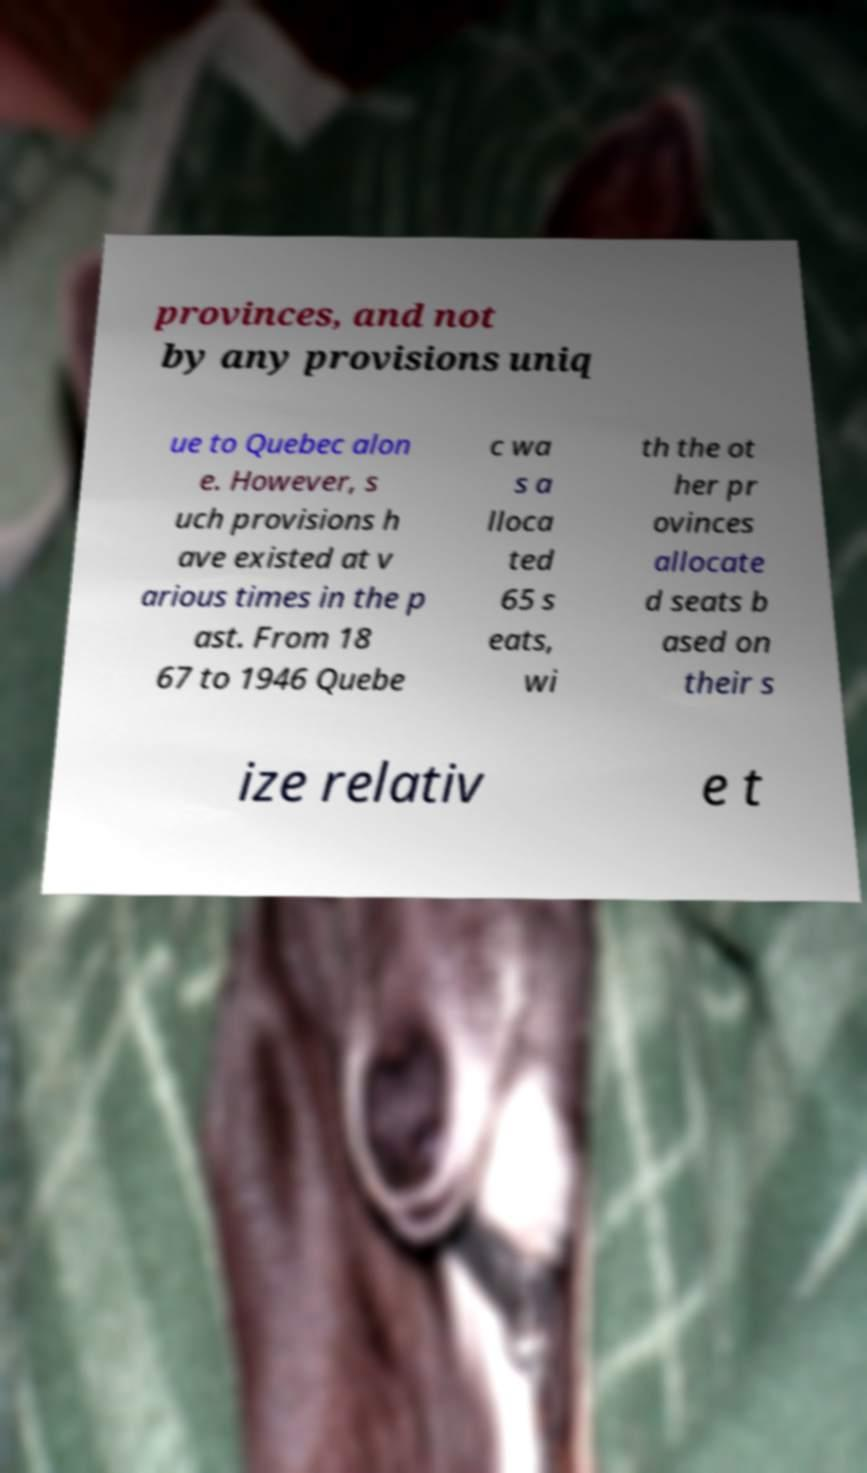Can you read and provide the text displayed in the image?This photo seems to have some interesting text. Can you extract and type it out for me? provinces, and not by any provisions uniq ue to Quebec alon e. However, s uch provisions h ave existed at v arious times in the p ast. From 18 67 to 1946 Quebe c wa s a lloca ted 65 s eats, wi th the ot her pr ovinces allocate d seats b ased on their s ize relativ e t 